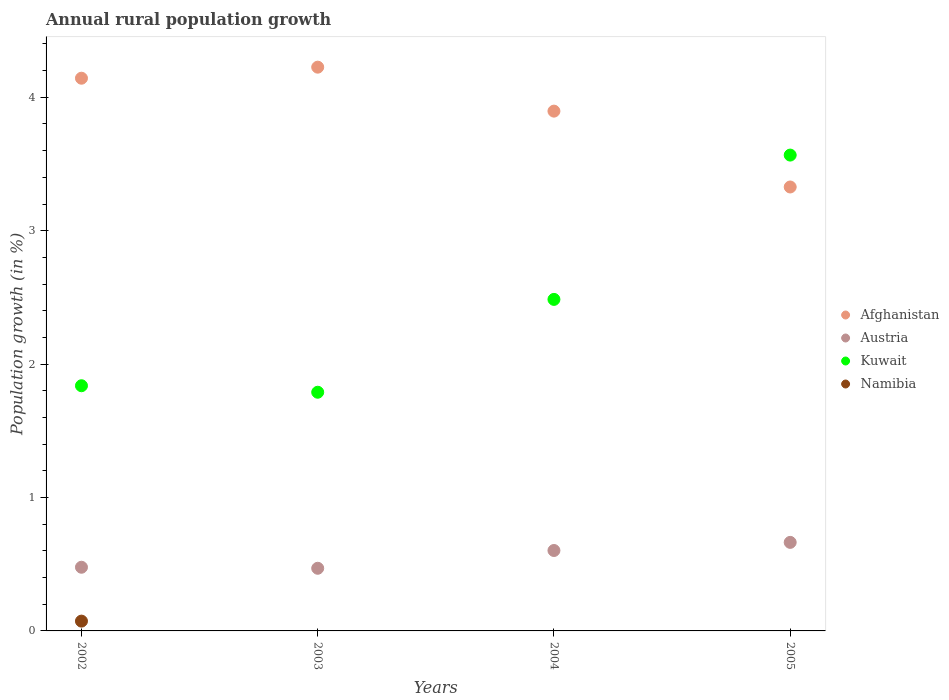Is the number of dotlines equal to the number of legend labels?
Provide a short and direct response. No. What is the percentage of rural population growth in Austria in 2003?
Offer a terse response. 0.47. Across all years, what is the maximum percentage of rural population growth in Kuwait?
Provide a succinct answer. 3.57. Across all years, what is the minimum percentage of rural population growth in Namibia?
Make the answer very short. 0. In which year was the percentage of rural population growth in Kuwait maximum?
Provide a succinct answer. 2005. What is the total percentage of rural population growth in Austria in the graph?
Your answer should be compact. 2.21. What is the difference between the percentage of rural population growth in Kuwait in 2002 and that in 2005?
Give a very brief answer. -1.73. What is the difference between the percentage of rural population growth in Afghanistan in 2004 and the percentage of rural population growth in Namibia in 2002?
Ensure brevity in your answer.  3.82. What is the average percentage of rural population growth in Austria per year?
Your answer should be very brief. 0.55. In the year 2005, what is the difference between the percentage of rural population growth in Kuwait and percentage of rural population growth in Austria?
Offer a very short reply. 2.9. In how many years, is the percentage of rural population growth in Namibia greater than 0.6000000000000001 %?
Ensure brevity in your answer.  0. What is the ratio of the percentage of rural population growth in Austria in 2003 to that in 2004?
Offer a very short reply. 0.78. Is the difference between the percentage of rural population growth in Kuwait in 2002 and 2004 greater than the difference between the percentage of rural population growth in Austria in 2002 and 2004?
Ensure brevity in your answer.  No. What is the difference between the highest and the second highest percentage of rural population growth in Afghanistan?
Ensure brevity in your answer.  0.08. What is the difference between the highest and the lowest percentage of rural population growth in Austria?
Provide a short and direct response. 0.19. In how many years, is the percentage of rural population growth in Austria greater than the average percentage of rural population growth in Austria taken over all years?
Ensure brevity in your answer.  2. Is the sum of the percentage of rural population growth in Afghanistan in 2002 and 2004 greater than the maximum percentage of rural population growth in Austria across all years?
Provide a succinct answer. Yes. Is it the case that in every year, the sum of the percentage of rural population growth in Austria and percentage of rural population growth in Kuwait  is greater than the sum of percentage of rural population growth in Namibia and percentage of rural population growth in Afghanistan?
Your answer should be compact. Yes. Is the percentage of rural population growth in Austria strictly greater than the percentage of rural population growth in Namibia over the years?
Offer a terse response. Yes. What is the difference between two consecutive major ticks on the Y-axis?
Provide a short and direct response. 1. How are the legend labels stacked?
Provide a succinct answer. Vertical. What is the title of the graph?
Provide a short and direct response. Annual rural population growth. What is the label or title of the X-axis?
Offer a very short reply. Years. What is the label or title of the Y-axis?
Provide a succinct answer. Population growth (in %). What is the Population growth (in %) of Afghanistan in 2002?
Offer a very short reply. 4.14. What is the Population growth (in %) of Austria in 2002?
Offer a terse response. 0.48. What is the Population growth (in %) of Kuwait in 2002?
Your response must be concise. 1.84. What is the Population growth (in %) of Namibia in 2002?
Your response must be concise. 0.07. What is the Population growth (in %) of Afghanistan in 2003?
Ensure brevity in your answer.  4.23. What is the Population growth (in %) in Austria in 2003?
Offer a terse response. 0.47. What is the Population growth (in %) of Kuwait in 2003?
Provide a succinct answer. 1.79. What is the Population growth (in %) of Afghanistan in 2004?
Provide a short and direct response. 3.9. What is the Population growth (in %) of Austria in 2004?
Provide a short and direct response. 0.6. What is the Population growth (in %) in Kuwait in 2004?
Make the answer very short. 2.49. What is the Population growth (in %) of Namibia in 2004?
Provide a short and direct response. 0. What is the Population growth (in %) in Afghanistan in 2005?
Provide a short and direct response. 3.33. What is the Population growth (in %) in Austria in 2005?
Offer a terse response. 0.66. What is the Population growth (in %) in Kuwait in 2005?
Your answer should be very brief. 3.57. Across all years, what is the maximum Population growth (in %) in Afghanistan?
Offer a very short reply. 4.23. Across all years, what is the maximum Population growth (in %) of Austria?
Your response must be concise. 0.66. Across all years, what is the maximum Population growth (in %) in Kuwait?
Provide a short and direct response. 3.57. Across all years, what is the maximum Population growth (in %) in Namibia?
Your answer should be very brief. 0.07. Across all years, what is the minimum Population growth (in %) of Afghanistan?
Ensure brevity in your answer.  3.33. Across all years, what is the minimum Population growth (in %) of Austria?
Your answer should be very brief. 0.47. Across all years, what is the minimum Population growth (in %) in Kuwait?
Give a very brief answer. 1.79. What is the total Population growth (in %) of Afghanistan in the graph?
Keep it short and to the point. 15.59. What is the total Population growth (in %) of Austria in the graph?
Ensure brevity in your answer.  2.21. What is the total Population growth (in %) in Kuwait in the graph?
Offer a very short reply. 9.68. What is the total Population growth (in %) in Namibia in the graph?
Your response must be concise. 0.07. What is the difference between the Population growth (in %) in Afghanistan in 2002 and that in 2003?
Give a very brief answer. -0.08. What is the difference between the Population growth (in %) in Austria in 2002 and that in 2003?
Offer a very short reply. 0.01. What is the difference between the Population growth (in %) of Kuwait in 2002 and that in 2003?
Your answer should be very brief. 0.05. What is the difference between the Population growth (in %) in Afghanistan in 2002 and that in 2004?
Offer a very short reply. 0.25. What is the difference between the Population growth (in %) in Austria in 2002 and that in 2004?
Offer a terse response. -0.13. What is the difference between the Population growth (in %) of Kuwait in 2002 and that in 2004?
Your response must be concise. -0.65. What is the difference between the Population growth (in %) in Afghanistan in 2002 and that in 2005?
Ensure brevity in your answer.  0.82. What is the difference between the Population growth (in %) in Austria in 2002 and that in 2005?
Your answer should be compact. -0.19. What is the difference between the Population growth (in %) of Kuwait in 2002 and that in 2005?
Offer a very short reply. -1.73. What is the difference between the Population growth (in %) of Afghanistan in 2003 and that in 2004?
Your answer should be very brief. 0.33. What is the difference between the Population growth (in %) in Austria in 2003 and that in 2004?
Offer a very short reply. -0.13. What is the difference between the Population growth (in %) in Kuwait in 2003 and that in 2004?
Make the answer very short. -0.7. What is the difference between the Population growth (in %) of Afghanistan in 2003 and that in 2005?
Ensure brevity in your answer.  0.9. What is the difference between the Population growth (in %) in Austria in 2003 and that in 2005?
Offer a very short reply. -0.19. What is the difference between the Population growth (in %) in Kuwait in 2003 and that in 2005?
Ensure brevity in your answer.  -1.78. What is the difference between the Population growth (in %) of Afghanistan in 2004 and that in 2005?
Your response must be concise. 0.57. What is the difference between the Population growth (in %) of Austria in 2004 and that in 2005?
Provide a succinct answer. -0.06. What is the difference between the Population growth (in %) in Kuwait in 2004 and that in 2005?
Your response must be concise. -1.08. What is the difference between the Population growth (in %) of Afghanistan in 2002 and the Population growth (in %) of Austria in 2003?
Give a very brief answer. 3.67. What is the difference between the Population growth (in %) in Afghanistan in 2002 and the Population growth (in %) in Kuwait in 2003?
Keep it short and to the point. 2.35. What is the difference between the Population growth (in %) of Austria in 2002 and the Population growth (in %) of Kuwait in 2003?
Give a very brief answer. -1.31. What is the difference between the Population growth (in %) of Afghanistan in 2002 and the Population growth (in %) of Austria in 2004?
Give a very brief answer. 3.54. What is the difference between the Population growth (in %) in Afghanistan in 2002 and the Population growth (in %) in Kuwait in 2004?
Offer a terse response. 1.66. What is the difference between the Population growth (in %) in Austria in 2002 and the Population growth (in %) in Kuwait in 2004?
Your answer should be very brief. -2.01. What is the difference between the Population growth (in %) of Afghanistan in 2002 and the Population growth (in %) of Austria in 2005?
Offer a very short reply. 3.48. What is the difference between the Population growth (in %) of Afghanistan in 2002 and the Population growth (in %) of Kuwait in 2005?
Your answer should be compact. 0.58. What is the difference between the Population growth (in %) in Austria in 2002 and the Population growth (in %) in Kuwait in 2005?
Provide a short and direct response. -3.09. What is the difference between the Population growth (in %) of Afghanistan in 2003 and the Population growth (in %) of Austria in 2004?
Give a very brief answer. 3.62. What is the difference between the Population growth (in %) of Afghanistan in 2003 and the Population growth (in %) of Kuwait in 2004?
Give a very brief answer. 1.74. What is the difference between the Population growth (in %) in Austria in 2003 and the Population growth (in %) in Kuwait in 2004?
Provide a succinct answer. -2.02. What is the difference between the Population growth (in %) in Afghanistan in 2003 and the Population growth (in %) in Austria in 2005?
Offer a very short reply. 3.56. What is the difference between the Population growth (in %) in Afghanistan in 2003 and the Population growth (in %) in Kuwait in 2005?
Keep it short and to the point. 0.66. What is the difference between the Population growth (in %) in Austria in 2003 and the Population growth (in %) in Kuwait in 2005?
Give a very brief answer. -3.1. What is the difference between the Population growth (in %) in Afghanistan in 2004 and the Population growth (in %) in Austria in 2005?
Keep it short and to the point. 3.23. What is the difference between the Population growth (in %) of Afghanistan in 2004 and the Population growth (in %) of Kuwait in 2005?
Make the answer very short. 0.33. What is the difference between the Population growth (in %) of Austria in 2004 and the Population growth (in %) of Kuwait in 2005?
Your response must be concise. -2.96. What is the average Population growth (in %) of Afghanistan per year?
Offer a terse response. 3.9. What is the average Population growth (in %) of Austria per year?
Give a very brief answer. 0.55. What is the average Population growth (in %) in Kuwait per year?
Your answer should be very brief. 2.42. What is the average Population growth (in %) in Namibia per year?
Provide a short and direct response. 0.02. In the year 2002, what is the difference between the Population growth (in %) of Afghanistan and Population growth (in %) of Austria?
Your response must be concise. 3.67. In the year 2002, what is the difference between the Population growth (in %) of Afghanistan and Population growth (in %) of Kuwait?
Provide a succinct answer. 2.31. In the year 2002, what is the difference between the Population growth (in %) in Afghanistan and Population growth (in %) in Namibia?
Your answer should be very brief. 4.07. In the year 2002, what is the difference between the Population growth (in %) of Austria and Population growth (in %) of Kuwait?
Make the answer very short. -1.36. In the year 2002, what is the difference between the Population growth (in %) of Austria and Population growth (in %) of Namibia?
Keep it short and to the point. 0.4. In the year 2002, what is the difference between the Population growth (in %) of Kuwait and Population growth (in %) of Namibia?
Ensure brevity in your answer.  1.76. In the year 2003, what is the difference between the Population growth (in %) of Afghanistan and Population growth (in %) of Austria?
Offer a very short reply. 3.76. In the year 2003, what is the difference between the Population growth (in %) in Afghanistan and Population growth (in %) in Kuwait?
Your response must be concise. 2.44. In the year 2003, what is the difference between the Population growth (in %) of Austria and Population growth (in %) of Kuwait?
Offer a terse response. -1.32. In the year 2004, what is the difference between the Population growth (in %) of Afghanistan and Population growth (in %) of Austria?
Give a very brief answer. 3.29. In the year 2004, what is the difference between the Population growth (in %) in Afghanistan and Population growth (in %) in Kuwait?
Keep it short and to the point. 1.41. In the year 2004, what is the difference between the Population growth (in %) of Austria and Population growth (in %) of Kuwait?
Keep it short and to the point. -1.88. In the year 2005, what is the difference between the Population growth (in %) of Afghanistan and Population growth (in %) of Austria?
Keep it short and to the point. 2.66. In the year 2005, what is the difference between the Population growth (in %) of Afghanistan and Population growth (in %) of Kuwait?
Provide a succinct answer. -0.24. In the year 2005, what is the difference between the Population growth (in %) of Austria and Population growth (in %) of Kuwait?
Offer a terse response. -2.9. What is the ratio of the Population growth (in %) of Afghanistan in 2002 to that in 2003?
Your answer should be very brief. 0.98. What is the ratio of the Population growth (in %) in Austria in 2002 to that in 2003?
Give a very brief answer. 1.02. What is the ratio of the Population growth (in %) of Kuwait in 2002 to that in 2003?
Give a very brief answer. 1.03. What is the ratio of the Population growth (in %) in Afghanistan in 2002 to that in 2004?
Keep it short and to the point. 1.06. What is the ratio of the Population growth (in %) of Austria in 2002 to that in 2004?
Offer a very short reply. 0.79. What is the ratio of the Population growth (in %) of Kuwait in 2002 to that in 2004?
Provide a succinct answer. 0.74. What is the ratio of the Population growth (in %) of Afghanistan in 2002 to that in 2005?
Give a very brief answer. 1.25. What is the ratio of the Population growth (in %) of Austria in 2002 to that in 2005?
Your answer should be very brief. 0.72. What is the ratio of the Population growth (in %) in Kuwait in 2002 to that in 2005?
Ensure brevity in your answer.  0.52. What is the ratio of the Population growth (in %) of Afghanistan in 2003 to that in 2004?
Your answer should be compact. 1.08. What is the ratio of the Population growth (in %) in Austria in 2003 to that in 2004?
Offer a terse response. 0.78. What is the ratio of the Population growth (in %) in Kuwait in 2003 to that in 2004?
Give a very brief answer. 0.72. What is the ratio of the Population growth (in %) of Afghanistan in 2003 to that in 2005?
Your answer should be very brief. 1.27. What is the ratio of the Population growth (in %) of Austria in 2003 to that in 2005?
Your answer should be very brief. 0.71. What is the ratio of the Population growth (in %) in Kuwait in 2003 to that in 2005?
Offer a terse response. 0.5. What is the ratio of the Population growth (in %) in Afghanistan in 2004 to that in 2005?
Your answer should be compact. 1.17. What is the ratio of the Population growth (in %) of Austria in 2004 to that in 2005?
Your response must be concise. 0.91. What is the ratio of the Population growth (in %) in Kuwait in 2004 to that in 2005?
Your answer should be very brief. 0.7. What is the difference between the highest and the second highest Population growth (in %) of Afghanistan?
Make the answer very short. 0.08. What is the difference between the highest and the second highest Population growth (in %) of Austria?
Your answer should be very brief. 0.06. What is the difference between the highest and the second highest Population growth (in %) of Kuwait?
Give a very brief answer. 1.08. What is the difference between the highest and the lowest Population growth (in %) in Afghanistan?
Give a very brief answer. 0.9. What is the difference between the highest and the lowest Population growth (in %) of Austria?
Offer a terse response. 0.19. What is the difference between the highest and the lowest Population growth (in %) in Kuwait?
Offer a terse response. 1.78. What is the difference between the highest and the lowest Population growth (in %) in Namibia?
Your answer should be compact. 0.07. 